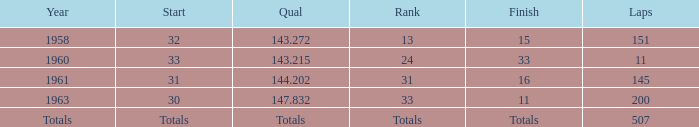What's the Finish rank of 31? 16.0. 